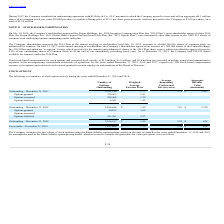From Finjan Holding's financial document, What are the respective outstanding options as at December 31, 2017 and 2018? The document shows two values: 2,341,340 and 2,486,646. From the document: "Outstanding – December 31, 2017 2,341,340 $ 1.77 5.78 $ 1,087 Outstanding – December 31, 2018 2,486,646 $ 1.89 7.01 $ 1,550..." Also, What are the respective outstanding options as at December 31, 2018 and 2019? The document shows two values: 2,486,646 and 2,356,197. From the document: "Outstanding – December 31, 2019 2,356,197 $ 1.89 5.93 $ 628 Outstanding – December 31, 2018 2,486,646 $ 1.89 7.01 $ 1,550..." Also, What are the respective outstanding and exercisable options at December 31, 2019? The document shows two values: 2,356,197 and 1,843,468. From the document: "Outstanding – December 31, 2019 2,356,197 $ 1.89 5.93 $ 628 Exercisable – December 31, 2019 1,843,468 $ 1.75 5.34 $ 624..." Also, can you calculate: What is the average number of outstanding options as at December 31, 2017 and 2018? To answer this question, I need to perform calculations using the financial data. The calculation is: (2,341,340 + 2,486,646)/2 , which equals 2413993. This is based on the information: "Outstanding – December 31, 2017 2,341,340 $ 1.77 5.78 $ 1,087 Outstanding – December 31, 2018 2,486,646 $ 1.89 7.01 $ 1,550..." The key data points involved are: 2,341,340, 2,486,646. Also, can you calculate: What is the percentage change in outstanding options between 2017 and 2018? To answer this question, I need to perform calculations using the financial data. The calculation is: (2,486,646 - 2,341,340)/2,341,340 , which equals 6.21 (percentage). This is based on the information: "Outstanding – December 31, 2017 2,341,340 $ 1.77 5.78 $ 1,087 Outstanding – December 31, 2018 2,486,646 $ 1.89 7.01 $ 1,550..." The key data points involved are: 2,341,340, 2,486,646. Also, can you calculate: What is the percentage change in outstanding options between 2018 and 2019? To answer this question, I need to perform calculations using the financial data. The calculation is: (2,356,197 - 2,486,646)/2,486,646 , which equals -5.25 (percentage). This is based on the information: "Outstanding – December 31, 2019 2,356,197 $ 1.89 5.93 $ 628 Outstanding – December 31, 2018 2,486,646 $ 1.89 7.01 $ 1,550..." The key data points involved are: 2,356,197, 2,486,646. 